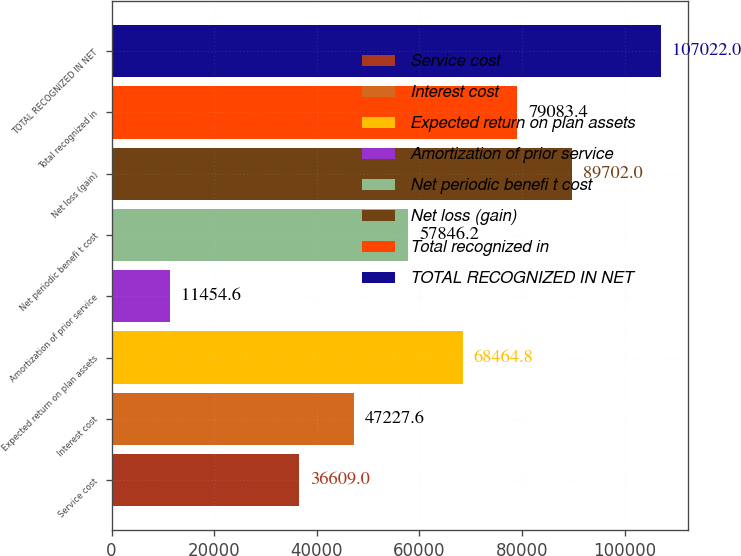Convert chart to OTSL. <chart><loc_0><loc_0><loc_500><loc_500><bar_chart><fcel>Service cost<fcel>Interest cost<fcel>Expected return on plan assets<fcel>Amortization of prior service<fcel>Net periodic benefi t cost<fcel>Net loss (gain)<fcel>Total recognized in<fcel>TOTAL RECOGNIZED IN NET<nl><fcel>36609<fcel>47227.6<fcel>68464.8<fcel>11454.6<fcel>57846.2<fcel>89702<fcel>79083.4<fcel>107022<nl></chart> 